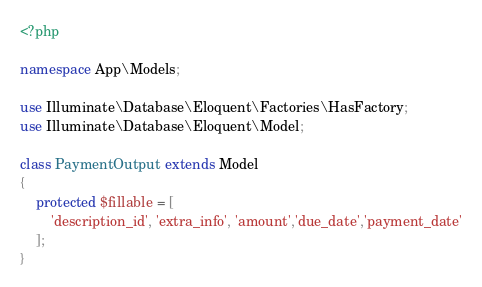<code> <loc_0><loc_0><loc_500><loc_500><_PHP_><?php

namespace App\Models;

use Illuminate\Database\Eloquent\Factories\HasFactory;
use Illuminate\Database\Eloquent\Model;

class PaymentOutput extends Model
{
    protected $fillable = [
        'description_id', 'extra_info', 'amount','due_date','payment_date'
    ];
}
</code> 